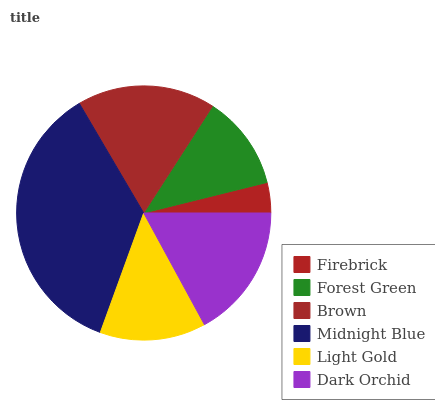Is Firebrick the minimum?
Answer yes or no. Yes. Is Midnight Blue the maximum?
Answer yes or no. Yes. Is Forest Green the minimum?
Answer yes or no. No. Is Forest Green the maximum?
Answer yes or no. No. Is Forest Green greater than Firebrick?
Answer yes or no. Yes. Is Firebrick less than Forest Green?
Answer yes or no. Yes. Is Firebrick greater than Forest Green?
Answer yes or no. No. Is Forest Green less than Firebrick?
Answer yes or no. No. Is Dark Orchid the high median?
Answer yes or no. Yes. Is Light Gold the low median?
Answer yes or no. Yes. Is Light Gold the high median?
Answer yes or no. No. Is Dark Orchid the low median?
Answer yes or no. No. 